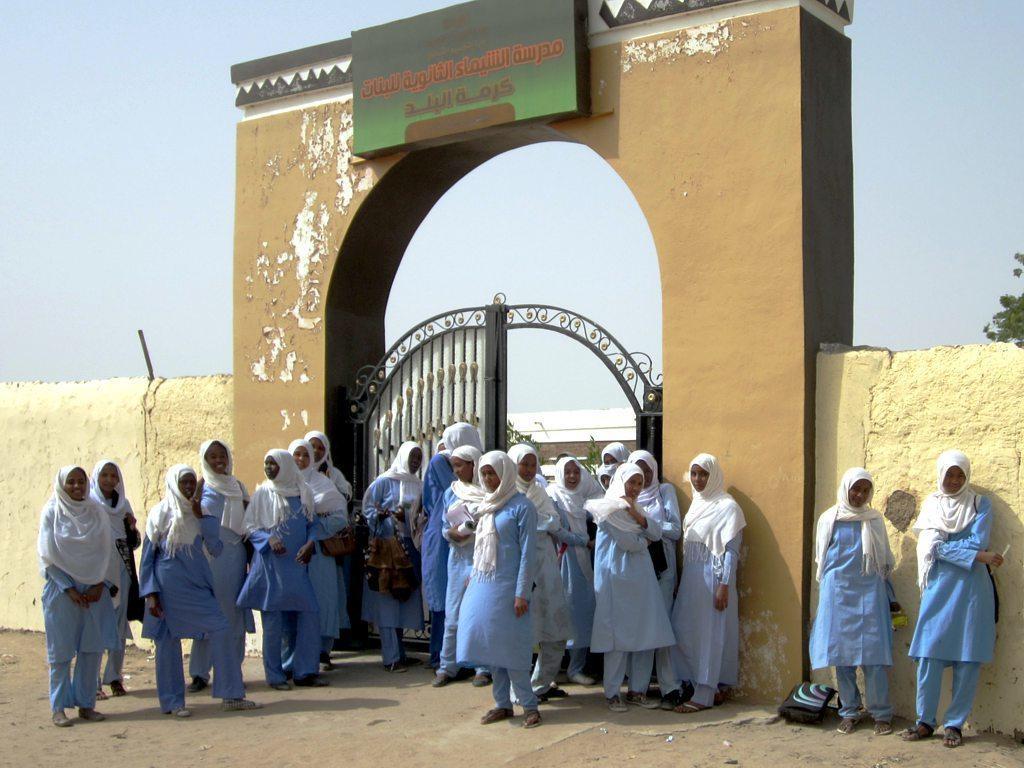In one or two sentences, can you explain what this image depicts? In this image there are group of people standing and in the background there is a wall gate and a board. On the board there is text which is in Urdu, in the background there is sky and tree. At the bottom there is walkway. 